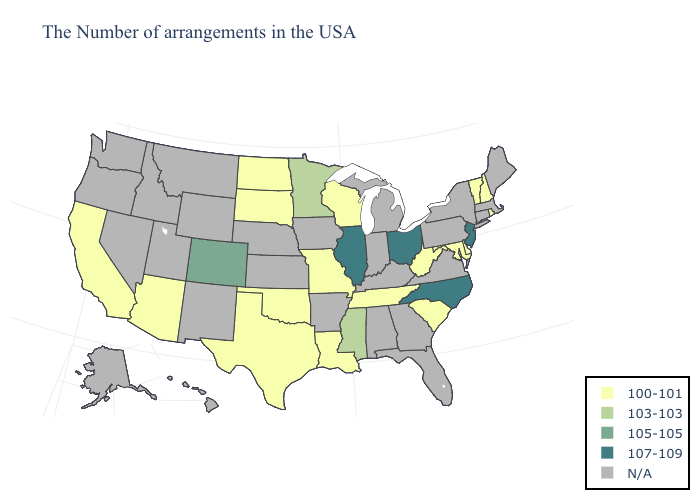What is the lowest value in the USA?
Answer briefly. 100-101. What is the value of Rhode Island?
Answer briefly. 100-101. Name the states that have a value in the range 107-109?
Write a very short answer. New Jersey, North Carolina, Ohio, Illinois. What is the highest value in the South ?
Be succinct. 107-109. Which states hav the highest value in the West?
Be succinct. Colorado. What is the lowest value in the USA?
Answer briefly. 100-101. Which states have the lowest value in the Northeast?
Answer briefly. Rhode Island, New Hampshire, Vermont. Does Illinois have the lowest value in the USA?
Answer briefly. No. What is the value of Kentucky?
Short answer required. N/A. How many symbols are there in the legend?
Quick response, please. 5. Name the states that have a value in the range 103-103?
Quick response, please. Mississippi, Minnesota. What is the value of North Carolina?
Short answer required. 107-109. Among the states that border Delaware , which have the lowest value?
Quick response, please. Maryland. 